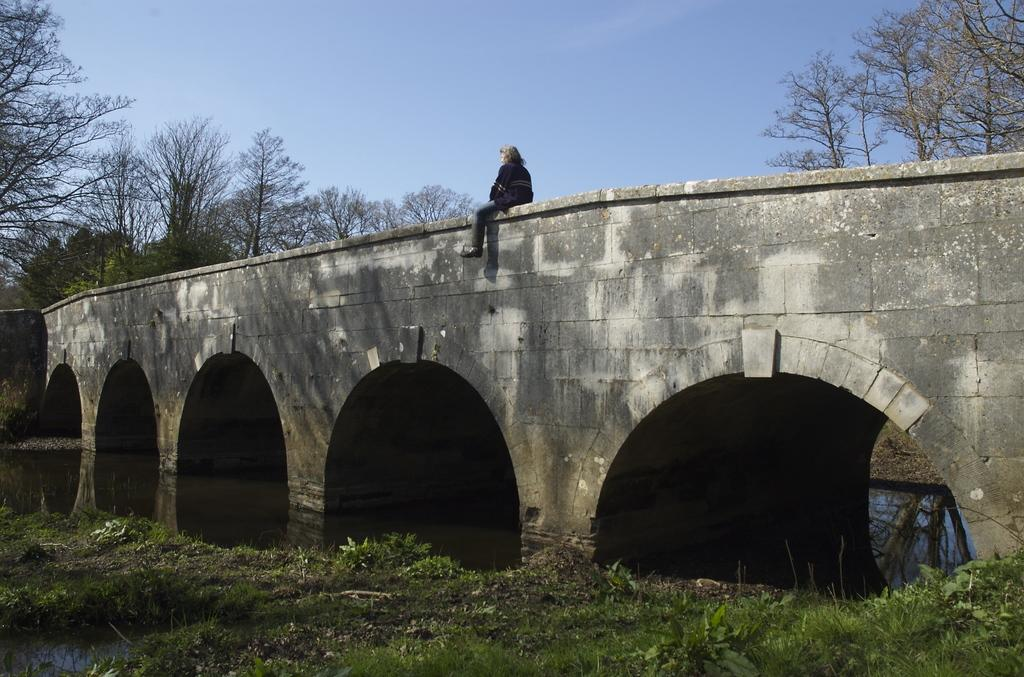What is the person in the image doing? The person is sitting on the bridge. What is under the bridge in the image? There is water under the bridge. What type of vegetation can be seen in the image? There are trees and bushes in the image. What can be seen in the background of the image? The sky is visible in the image. Who is the owner of the game being played in the image? There is no game being played in the image, so there is no owner to identify. 